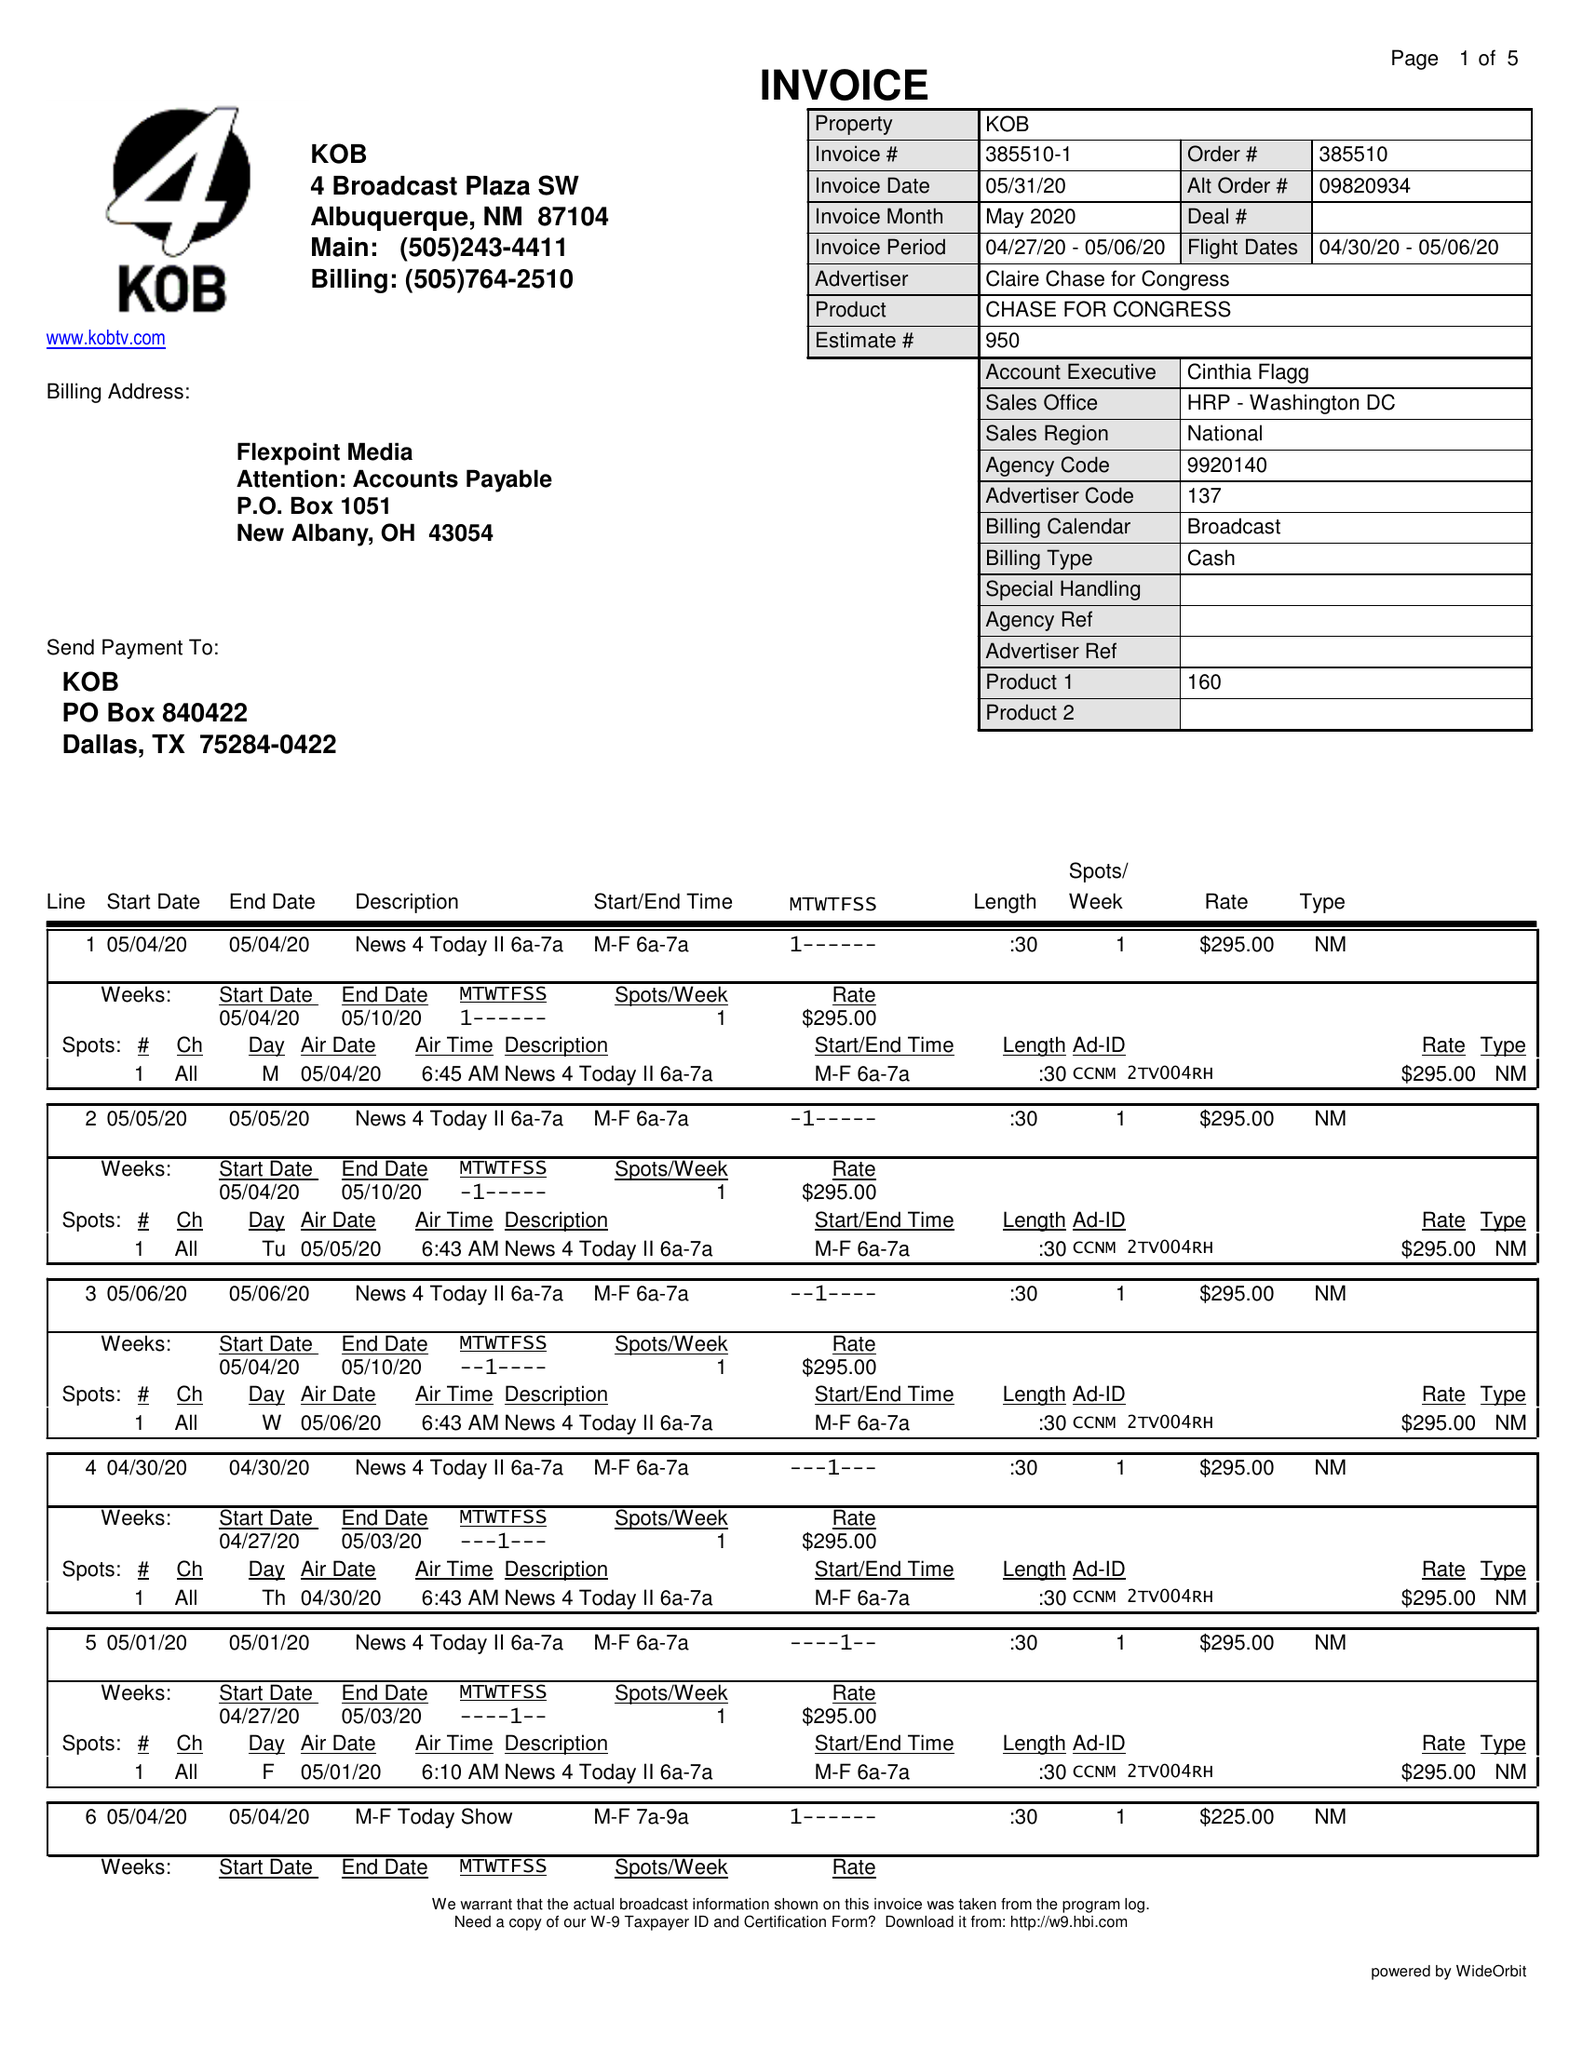What is the value for the gross_amount?
Answer the question using a single word or phrase. 7740.00 